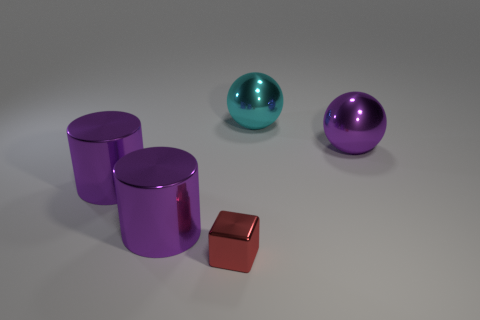Subtract all purple cylinders. How many were subtracted if there are1purple cylinders left? 1 Add 1 large purple things. How many objects exist? 6 Subtract all cyan balls. How many balls are left? 1 Add 4 tiny yellow metallic balls. How many tiny yellow metallic balls exist? 4 Subtract 0 cyan blocks. How many objects are left? 5 Subtract all spheres. How many objects are left? 3 Subtract all brown cylinders. Subtract all yellow blocks. How many cylinders are left? 2 Subtract all tiny cubes. Subtract all small brown shiny blocks. How many objects are left? 4 Add 1 cyan metal balls. How many cyan metal balls are left? 2 